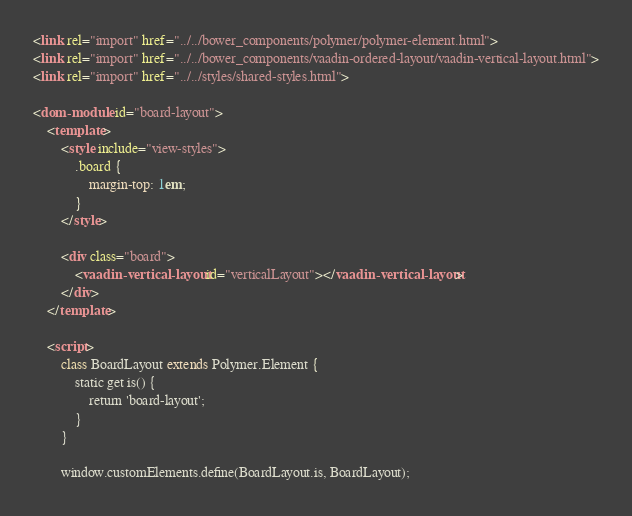<code> <loc_0><loc_0><loc_500><loc_500><_HTML_><link rel="import" href="../../bower_components/polymer/polymer-element.html">
<link rel="import" href="../../bower_components/vaadin-ordered-layout/vaadin-vertical-layout.html">
<link rel="import" href="../../styles/shared-styles.html">

<dom-module id="board-layout">
    <template>
        <style include="view-styles">
            .board {
                margin-top: 1em;
            }
        </style>

        <div class="board">
            <vaadin-vertical-layout id="verticalLayout"></vaadin-vertical-layout>
        </div>
    </template>

    <script>
        class BoardLayout extends Polymer.Element {
            static get is() {
                return 'board-layout';
            }
        }

        window.customElements.define(BoardLayout.is, BoardLayout);</code> 